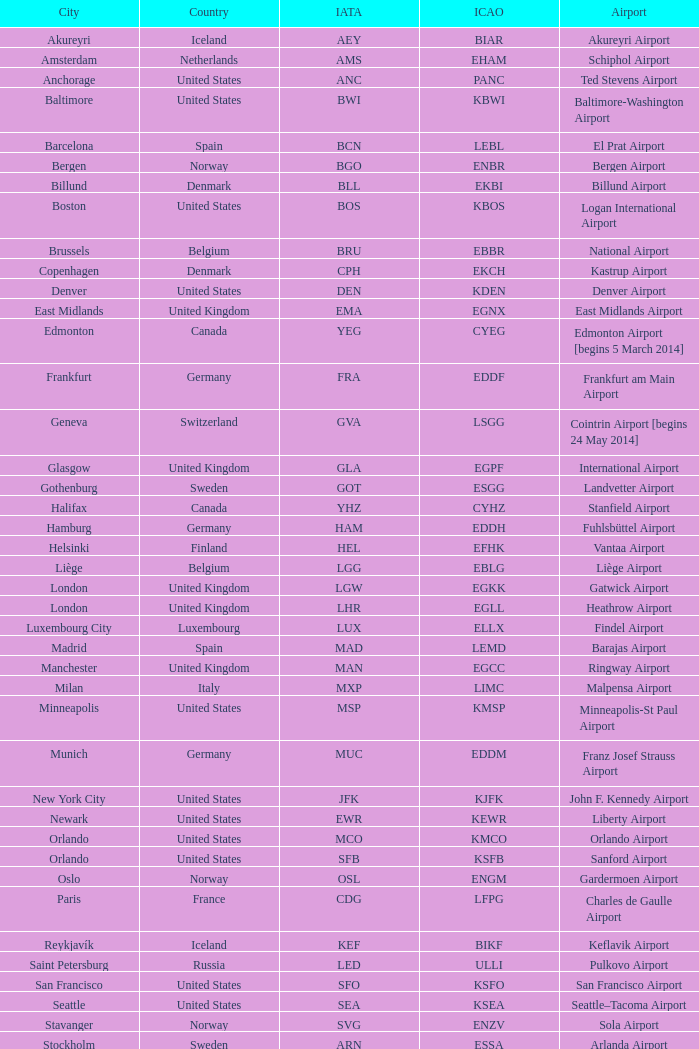What is the international civil aviation organization (icao) code assigned to frankfurt? EDDF. 